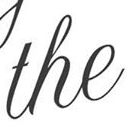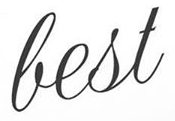What words are shown in these images in order, separated by a semicolon? the; best 